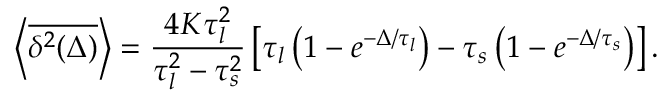Convert formula to latex. <formula><loc_0><loc_0><loc_500><loc_500>\left < \overline { { \delta ^ { 2 } ( \Delta ) } } \right > = \frac { 4 K \tau _ { l } ^ { 2 } } { \tau _ { l } ^ { 2 } - \tau _ { s } ^ { 2 } } \left [ \tau _ { l } \left ( 1 - e ^ { - \Delta / \tau _ { l } } \right ) - \tau _ { s } \left ( 1 - e ^ { - \Delta / \tau _ { s } } \right ) \right ] .</formula> 